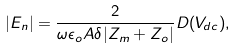Convert formula to latex. <formula><loc_0><loc_0><loc_500><loc_500>| E _ { n } | = \frac { 2 } { \omega \epsilon _ { o } A \delta | Z _ { m } + Z _ { o } | } D ( V _ { d c } ) ,</formula> 